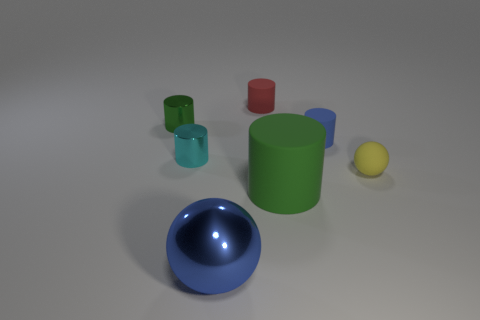Subtract all red matte cylinders. How many cylinders are left? 4 Add 2 green metal objects. How many objects exist? 9 Subtract all yellow spheres. How many green cylinders are left? 2 Subtract all blue cylinders. How many cylinders are left? 4 Subtract 1 spheres. How many spheres are left? 1 Subtract all spheres. How many objects are left? 5 Subtract all green spheres. Subtract all gray cylinders. How many spheres are left? 2 Subtract all red metal cylinders. Subtract all blue shiny objects. How many objects are left? 6 Add 1 blue balls. How many blue balls are left? 2 Add 2 small yellow metal balls. How many small yellow metal balls exist? 2 